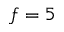Convert formula to latex. <formula><loc_0><loc_0><loc_500><loc_500>f = 5</formula> 